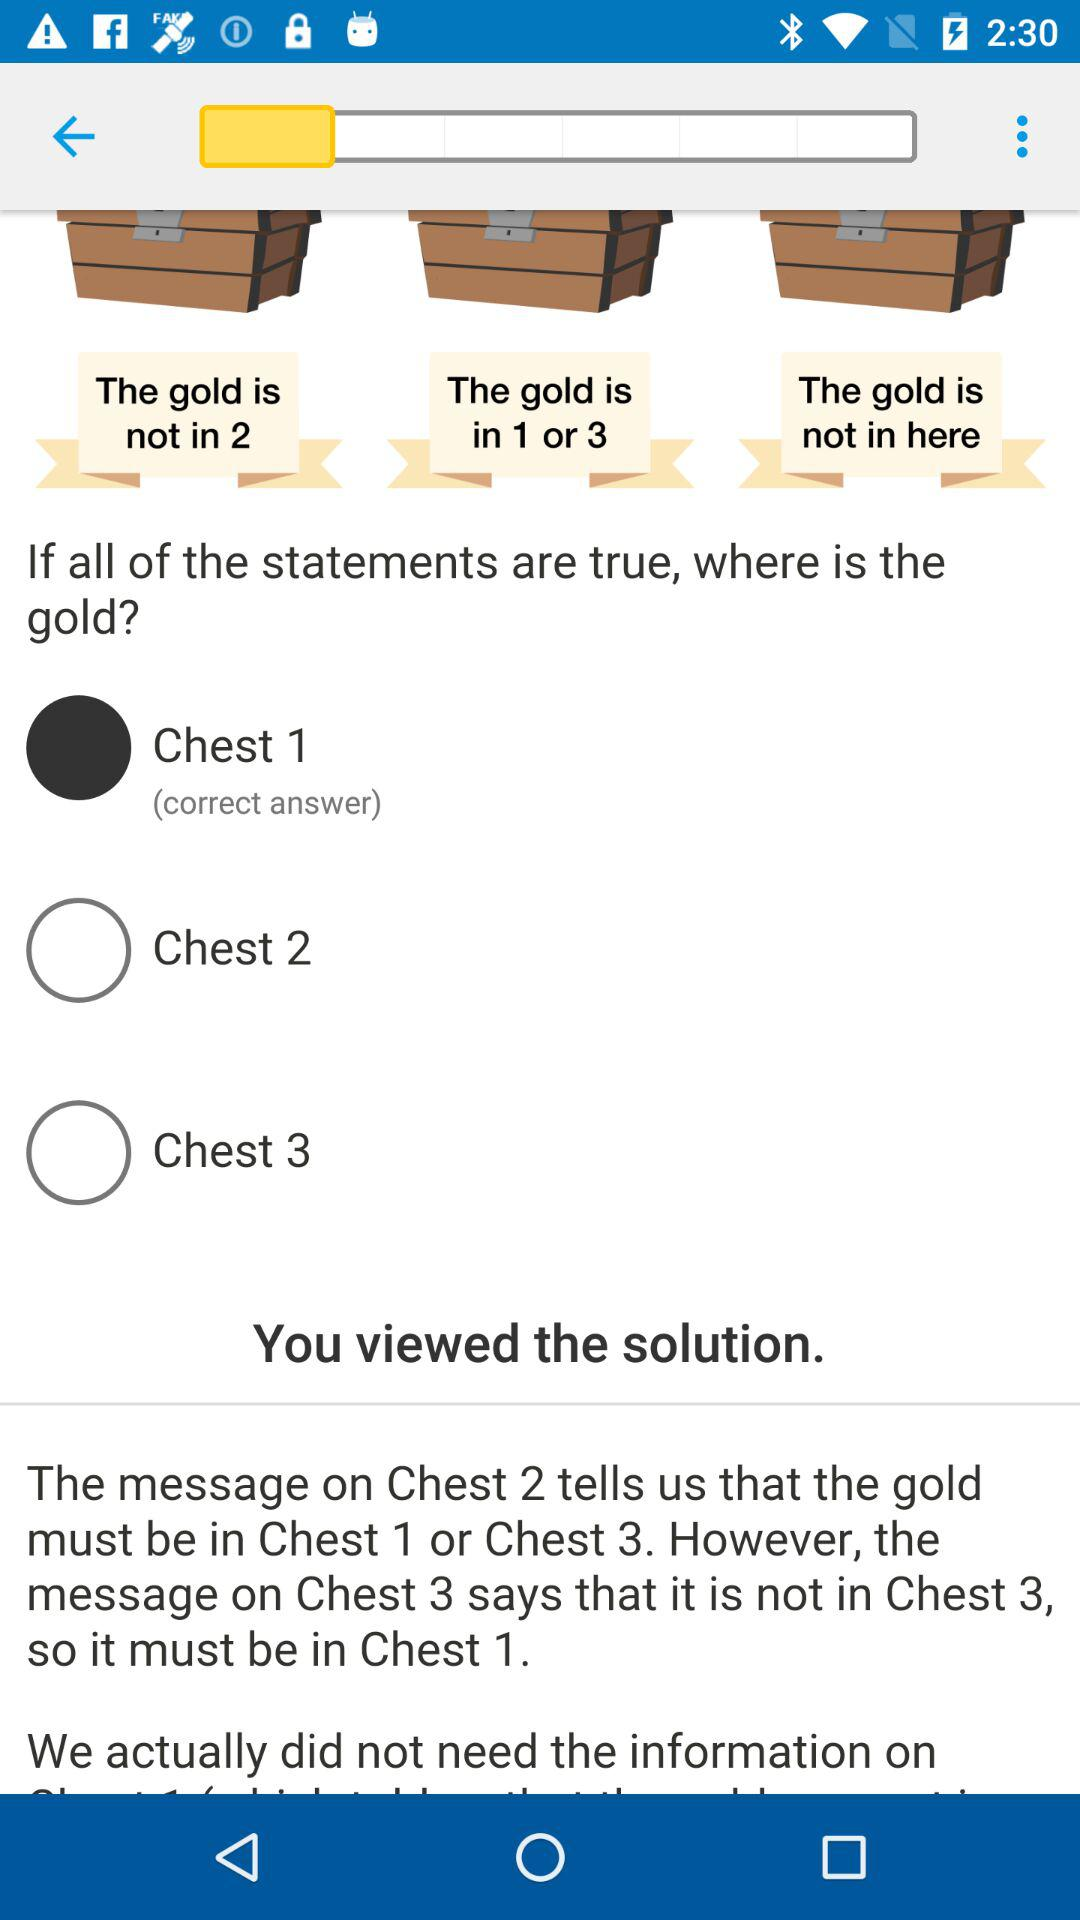How many chests are the gold in?
Answer the question using a single word or phrase. 1 